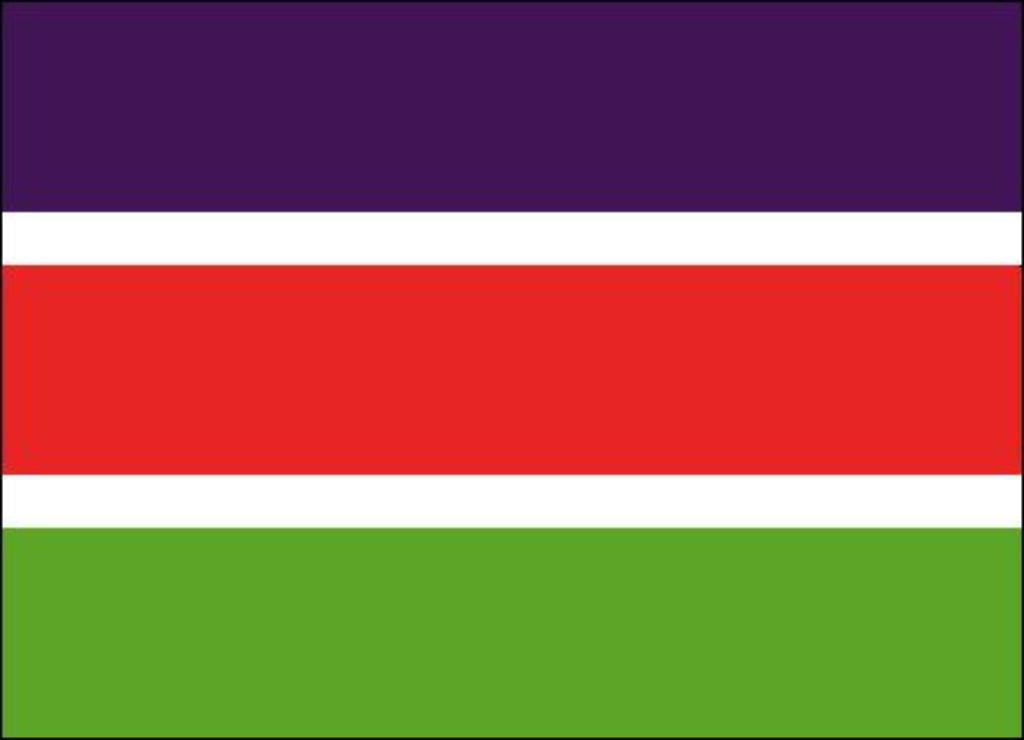Can you describe this image briefly? In this image there are four colors. We can see purple, white, red and green colors. 